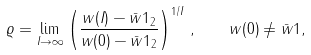Convert formula to latex. <formula><loc_0><loc_0><loc_500><loc_500>\varrho = \lim _ { I \rightarrow \infty } \left ( \frac { \| w ( I ) - \bar { w } 1 \| _ { 2 } } { \| w ( 0 ) - \bar { w } 1 \| _ { 2 } } \right ) ^ { 1 / I } \, , \quad w ( 0 ) \neq \bar { w } 1 ,</formula> 